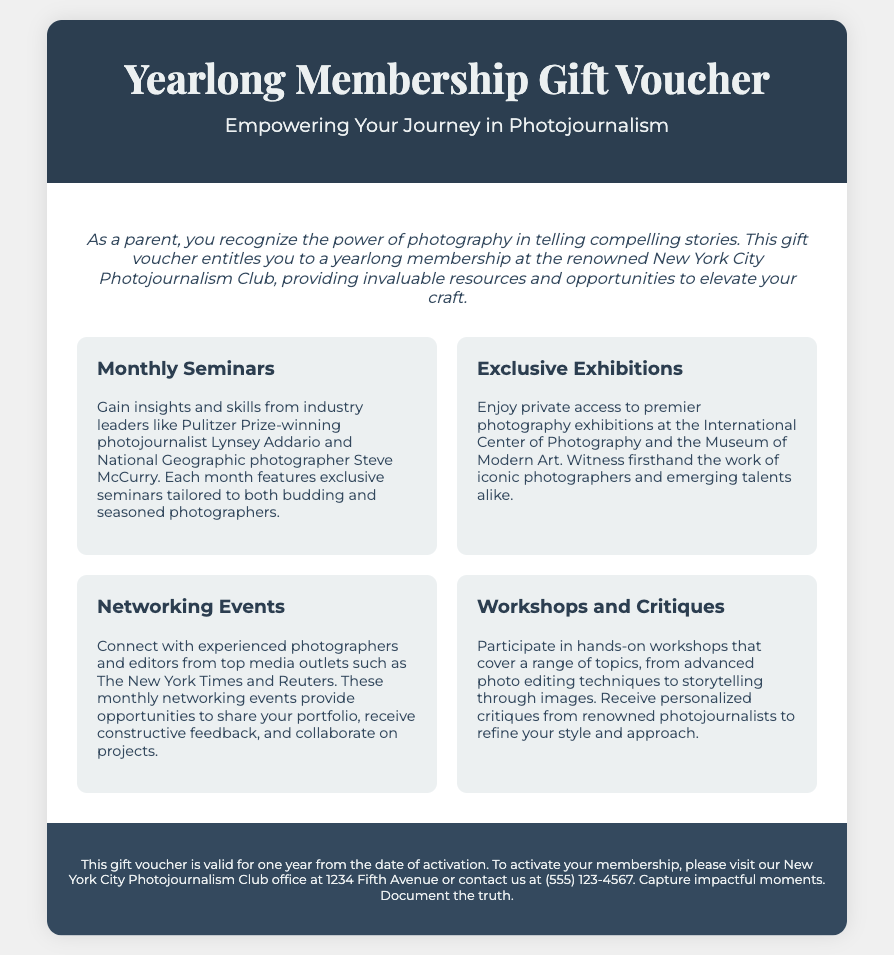What is the title of the document? The title of the document is mentioned prominently at the top.
Answer: Yearlong Membership Gift Voucher Who is the main audience for this gift voucher? The document clearly states that it is intended for parents encouraging photojournalism.
Answer: Parents What is the name of the organization associated with the gift voucher? The organization offering the membership is mentioned in the document.
Answer: New York City Photojournalism Club How long is the membership valid? The document specifies the duration of the membership.
Answer: One year What type of events are included monthly? The types of events provided each month are outlined in the content.
Answer: Seminars List one renowned photographer mentioned in the document. The document includes notable photographers who will lead seminars.
Answer: Lynsey Addario Where can the membership be activated? The activation location is provided in the footer of the document.
Answer: 1234 Fifth Avenue What are participants encouraged to do at networking events? The document describes specific activities at the networking events.
Answer: Share your portfolio 